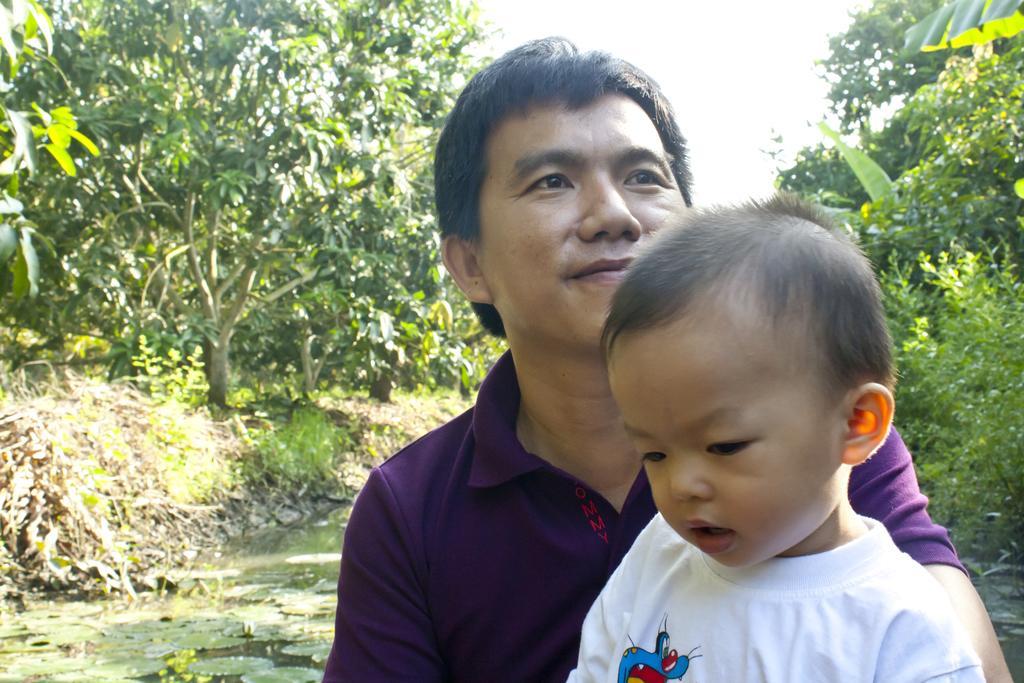Could you give a brief overview of what you see in this image? In this picture I can see a man and a kid, there are leaves on the water, there are plants, trees, and in the background there is sky. 